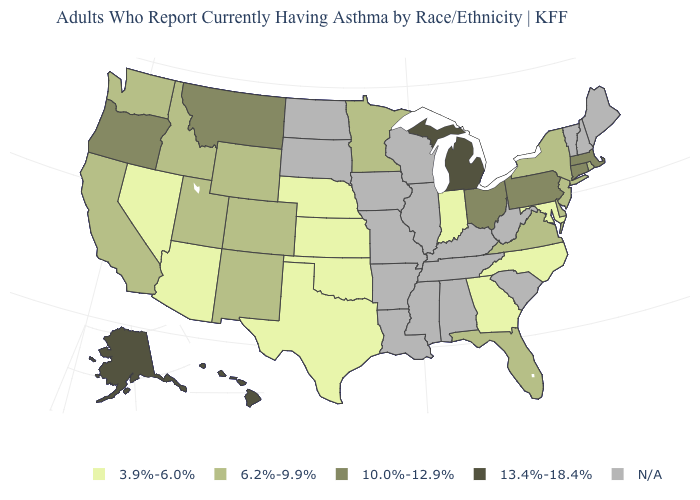Among the states that border Vermont , which have the highest value?
Quick response, please. Massachusetts. How many symbols are there in the legend?
Concise answer only. 5. Name the states that have a value in the range 3.9%-6.0%?
Quick response, please. Arizona, Georgia, Indiana, Kansas, Maryland, Nebraska, Nevada, North Carolina, Oklahoma, Texas. Does North Carolina have the highest value in the USA?
Give a very brief answer. No. What is the value of Washington?
Quick response, please. 6.2%-9.9%. Among the states that border Georgia , does Florida have the highest value?
Answer briefly. Yes. What is the lowest value in the West?
Short answer required. 3.9%-6.0%. Does New Jersey have the lowest value in the USA?
Quick response, please. No. Which states have the lowest value in the MidWest?
Keep it brief. Indiana, Kansas, Nebraska. Name the states that have a value in the range 10.0%-12.9%?
Keep it brief. Connecticut, Massachusetts, Montana, Ohio, Oregon, Pennsylvania. What is the highest value in the MidWest ?
Keep it brief. 13.4%-18.4%. What is the value of Colorado?
Give a very brief answer. 6.2%-9.9%. Does the map have missing data?
Write a very short answer. Yes. What is the highest value in the USA?
Give a very brief answer. 13.4%-18.4%. 